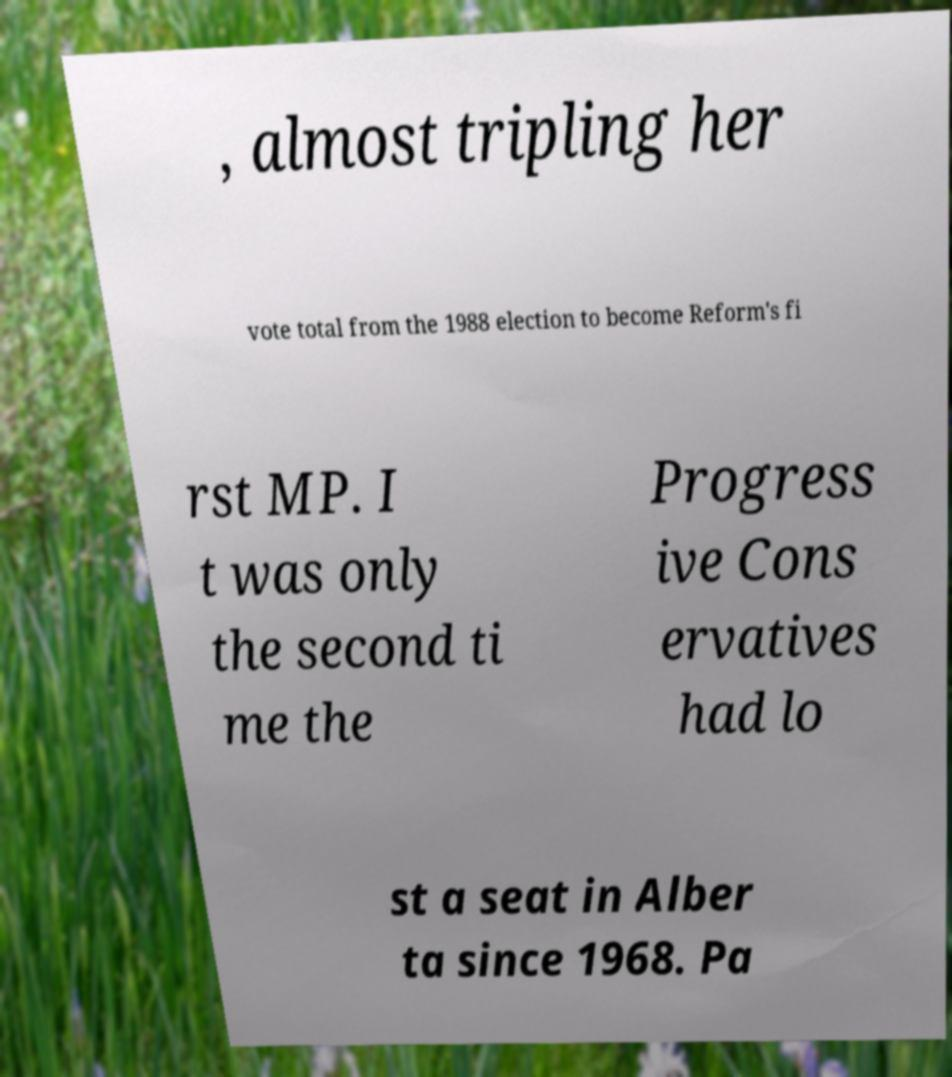What messages or text are displayed in this image? I need them in a readable, typed format. , almost tripling her vote total from the 1988 election to become Reform's fi rst MP. I t was only the second ti me the Progress ive Cons ervatives had lo st a seat in Alber ta since 1968. Pa 